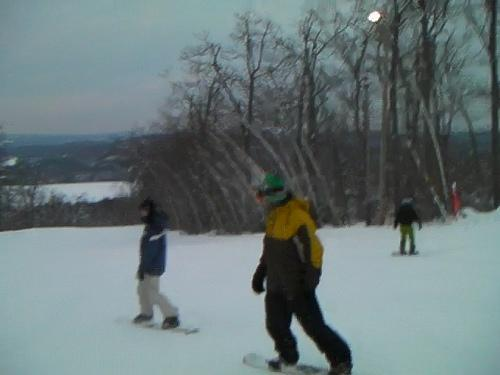Where does the white light come from? sun 